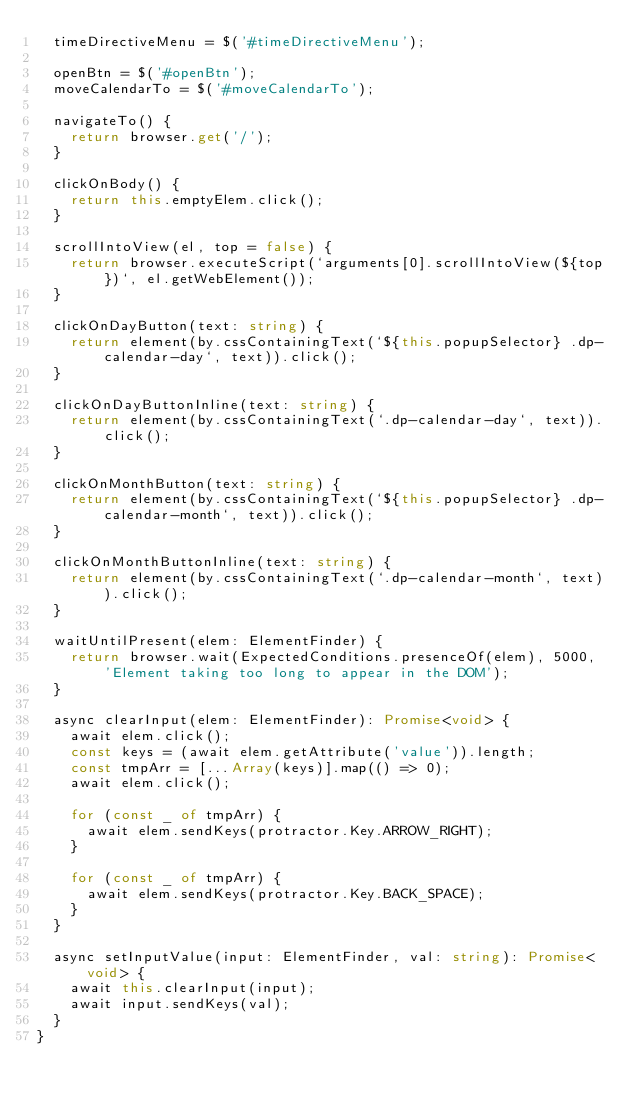Convert code to text. <code><loc_0><loc_0><loc_500><loc_500><_TypeScript_>  timeDirectiveMenu = $('#timeDirectiveMenu');

  openBtn = $('#openBtn');
  moveCalendarTo = $('#moveCalendarTo');

  navigateTo() {
    return browser.get('/');
  }

  clickOnBody() {
    return this.emptyElem.click();
  }

  scrollIntoView(el, top = false) {
    return browser.executeScript(`arguments[0].scrollIntoView(${top})`, el.getWebElement());
  }

  clickOnDayButton(text: string) {
    return element(by.cssContainingText(`${this.popupSelector} .dp-calendar-day`, text)).click();
  }

  clickOnDayButtonInline(text: string) {
    return element(by.cssContainingText(`.dp-calendar-day`, text)).click();
  }

  clickOnMonthButton(text: string) {
    return element(by.cssContainingText(`${this.popupSelector} .dp-calendar-month`, text)).click();
  }

  clickOnMonthButtonInline(text: string) {
    return element(by.cssContainingText(`.dp-calendar-month`, text)).click();
  }

  waitUntilPresent(elem: ElementFinder) {
    return browser.wait(ExpectedConditions.presenceOf(elem), 5000, 'Element taking too long to appear in the DOM');
  }

  async clearInput(elem: ElementFinder): Promise<void> {
    await elem.click();
    const keys = (await elem.getAttribute('value')).length;
    const tmpArr = [...Array(keys)].map(() => 0);
    await elem.click();

    for (const _ of tmpArr) {
      await elem.sendKeys(protractor.Key.ARROW_RIGHT);
    }

    for (const _ of tmpArr) {
      await elem.sendKeys(protractor.Key.BACK_SPACE);
    }
  }

  async setInputValue(input: ElementFinder, val: string): Promise<void> {
    await this.clearInput(input);
    await input.sendKeys(val);
  }
}
</code> 